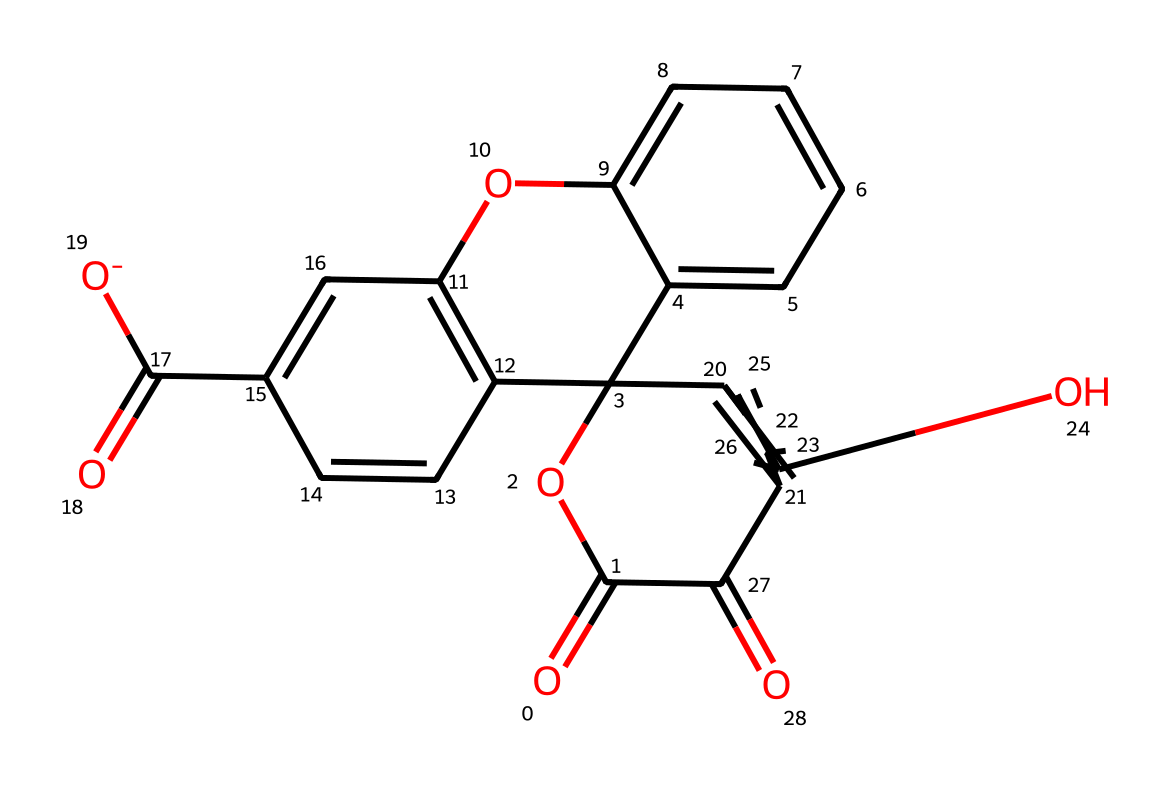What is the molecular formula of this dye? To find the molecular formula, we count the number of each type of atom present in the chemical structure. From the structure represented by the SMILES, we can identify that there are 15 carbon atoms, 10 hydrogen atoms, 5 oxygen atoms, and one anionic component. Thus, the molecular formula is C15H10O5.
Answer: C15H10O5 How many aromatic rings are present in this dye? By carefully analyzing the structure represented in the SMILES format, we can identify the number of distinct aromatic systems. The structure contains three aromatic rings visible from the connectivity of the atoms and the presence of alternating double bonds; thus, there are three aromatic rings.
Answer: 3 What type of functional group is present in this dye? The chemical structure indicates the presence of carboxylic acid functionalities, which is evidenced by the -COOH part linked in the structure. Moreover, the presence of multiple carbonyl (C=O) groups also contributes to its classification. Hence, the main functional group can be recognized as carboxylic acid.
Answer: carboxylic acid What is the charge of this dye in solution? The SMILES representation shows the presence of a negatively charged component due to the deprotonation of the carboxylic acid. This indicates that in solution, the compound would predominantly exist in a negatively charged form.
Answer: negative How does the presence of hydroxyl groups influence the solubility of this dye? Hydroxyl groups (-OH), which are present in the structure, are polar and capable of forming hydrogen bonds with water. This significantly enhances the dye's solubility in polar solvents, which is crucial for its use in nonlinear optical microscopy. Thus, they improve solubility.
Answer: enhances solubility What role do the carbonyl groups play in the fluorescent properties of this dye? Carbonyl groups (C=O) contribute to the conjugation and electron delocalization in the dye's structure, which is essential for the absorption and emission of light. This property is significant in fluorescent dyes, enhancing their ability to fluoresce under specific light conditions. Therefore, they enhance fluorescence.
Answer: enhance fluorescence 